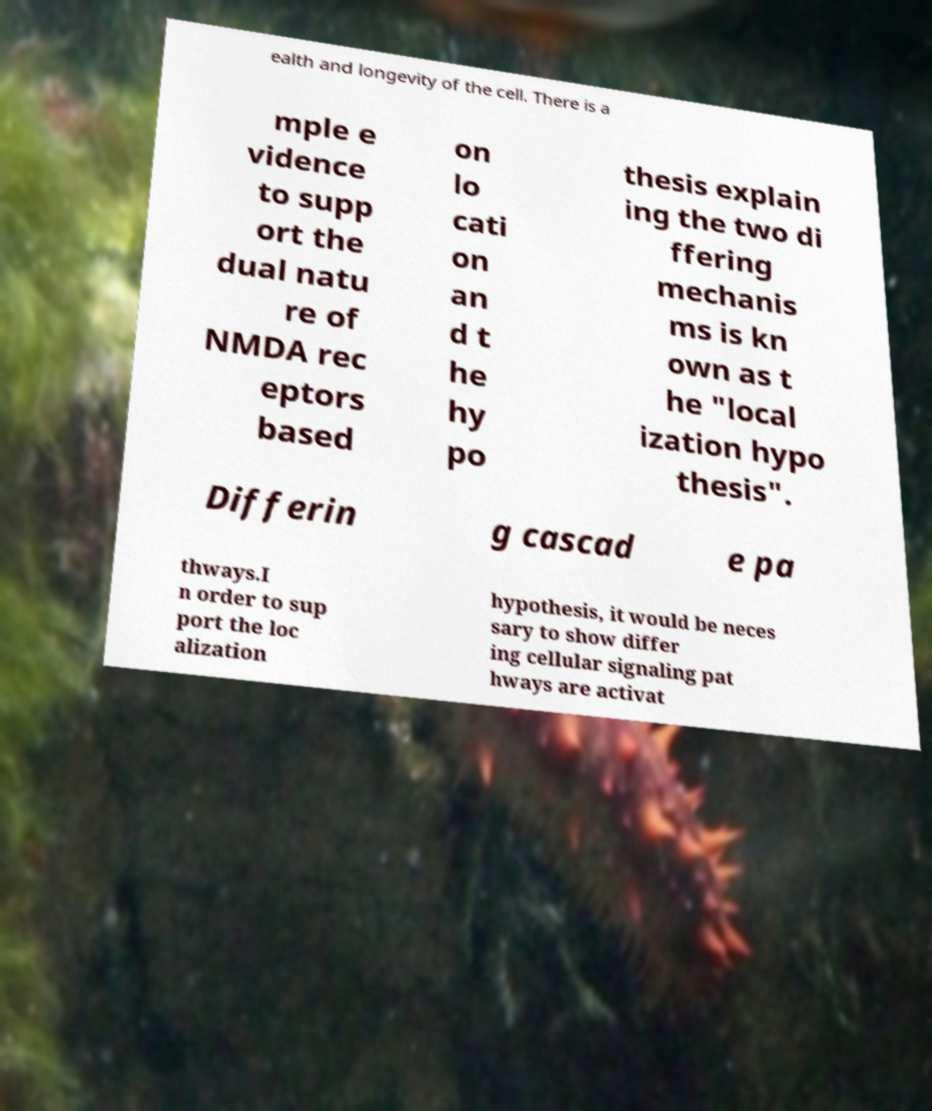Please identify and transcribe the text found in this image. ealth and longevity of the cell. There is a mple e vidence to supp ort the dual natu re of NMDA rec eptors based on lo cati on an d t he hy po thesis explain ing the two di ffering mechanis ms is kn own as t he "local ization hypo thesis". Differin g cascad e pa thways.I n order to sup port the loc alization hypothesis, it would be neces sary to show differ ing cellular signaling pat hways are activat 